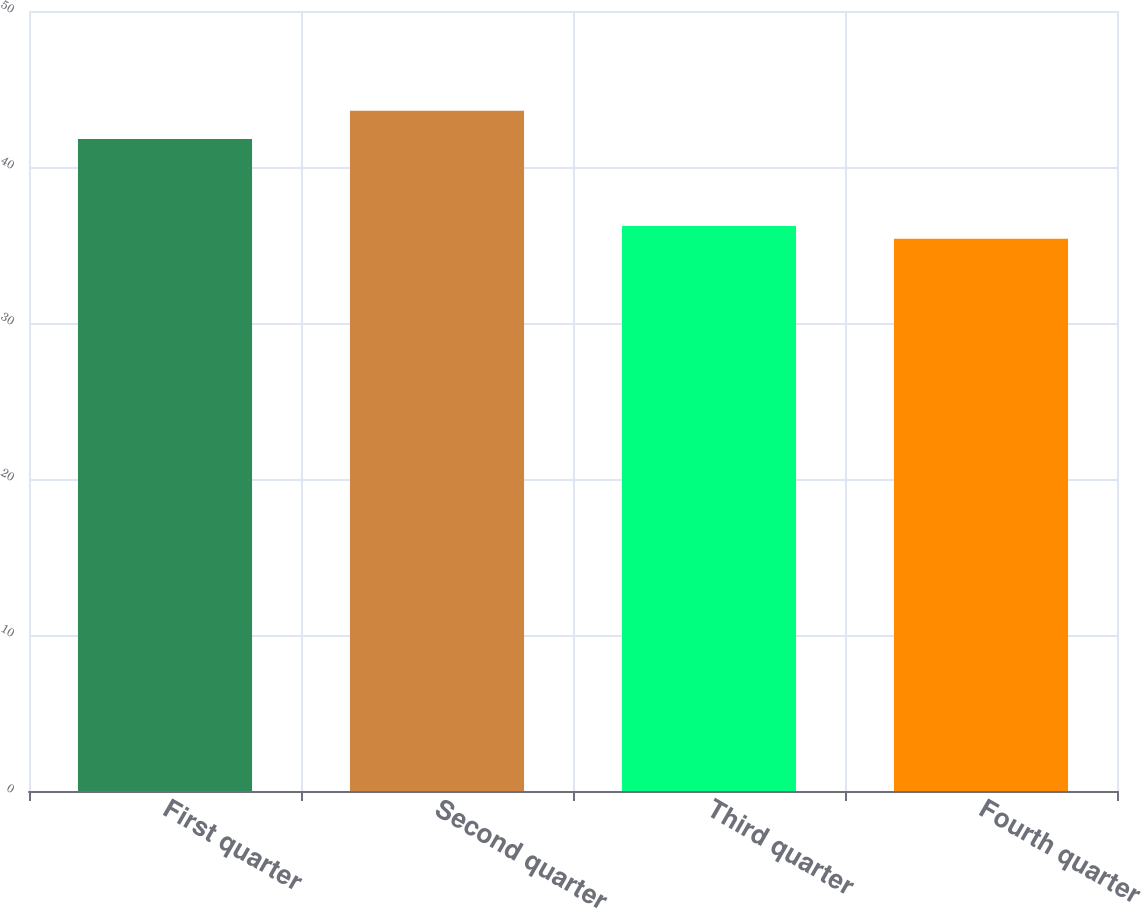<chart> <loc_0><loc_0><loc_500><loc_500><bar_chart><fcel>First quarter<fcel>Second quarter<fcel>Third quarter<fcel>Fourth quarter<nl><fcel>41.8<fcel>43.6<fcel>36.22<fcel>35.4<nl></chart> 